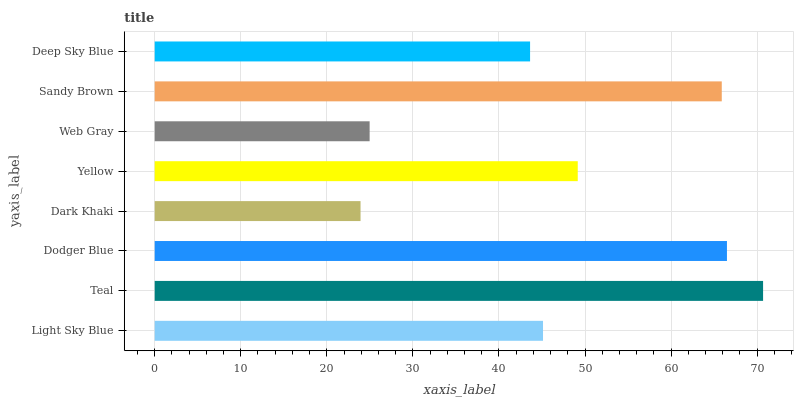Is Dark Khaki the minimum?
Answer yes or no. Yes. Is Teal the maximum?
Answer yes or no. Yes. Is Dodger Blue the minimum?
Answer yes or no. No. Is Dodger Blue the maximum?
Answer yes or no. No. Is Teal greater than Dodger Blue?
Answer yes or no. Yes. Is Dodger Blue less than Teal?
Answer yes or no. Yes. Is Dodger Blue greater than Teal?
Answer yes or no. No. Is Teal less than Dodger Blue?
Answer yes or no. No. Is Yellow the high median?
Answer yes or no. Yes. Is Light Sky Blue the low median?
Answer yes or no. Yes. Is Deep Sky Blue the high median?
Answer yes or no. No. Is Deep Sky Blue the low median?
Answer yes or no. No. 